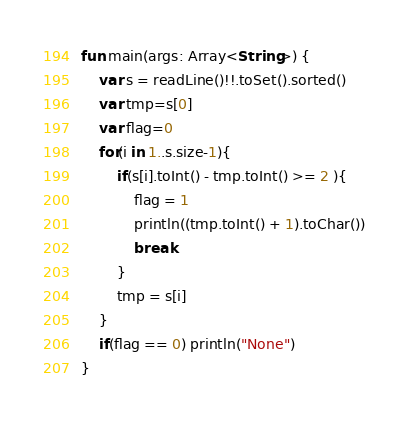Convert code to text. <code><loc_0><loc_0><loc_500><loc_500><_Kotlin_>fun main(args: Array<String>) {
    var s = readLine()!!.toSet().sorted()
    var tmp=s[0]
    var flag=0
    for(i in 1..s.size-1){
        if(s[i].toInt() - tmp.toInt() >= 2 ){
            flag = 1
            println((tmp.toInt() + 1).toChar())
            break
        }
        tmp = s[i]
    }
    if(flag == 0) println("None")
}
</code> 